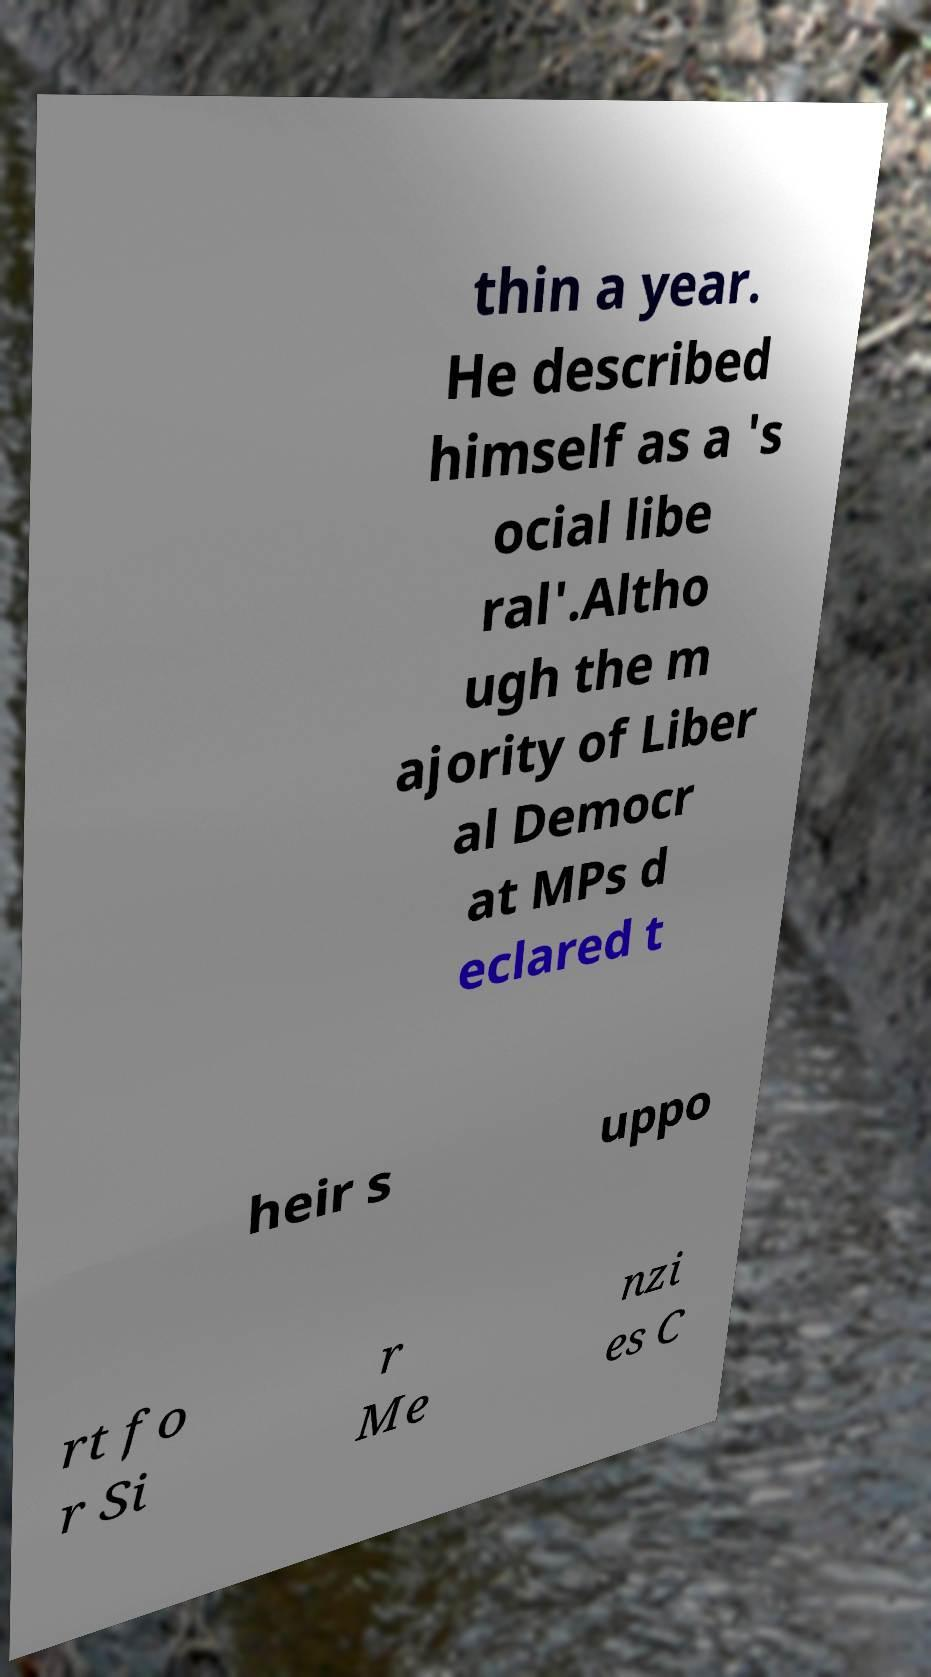Please read and relay the text visible in this image. What does it say? thin a year. He described himself as a 's ocial libe ral'.Altho ugh the m ajority of Liber al Democr at MPs d eclared t heir s uppo rt fo r Si r Me nzi es C 